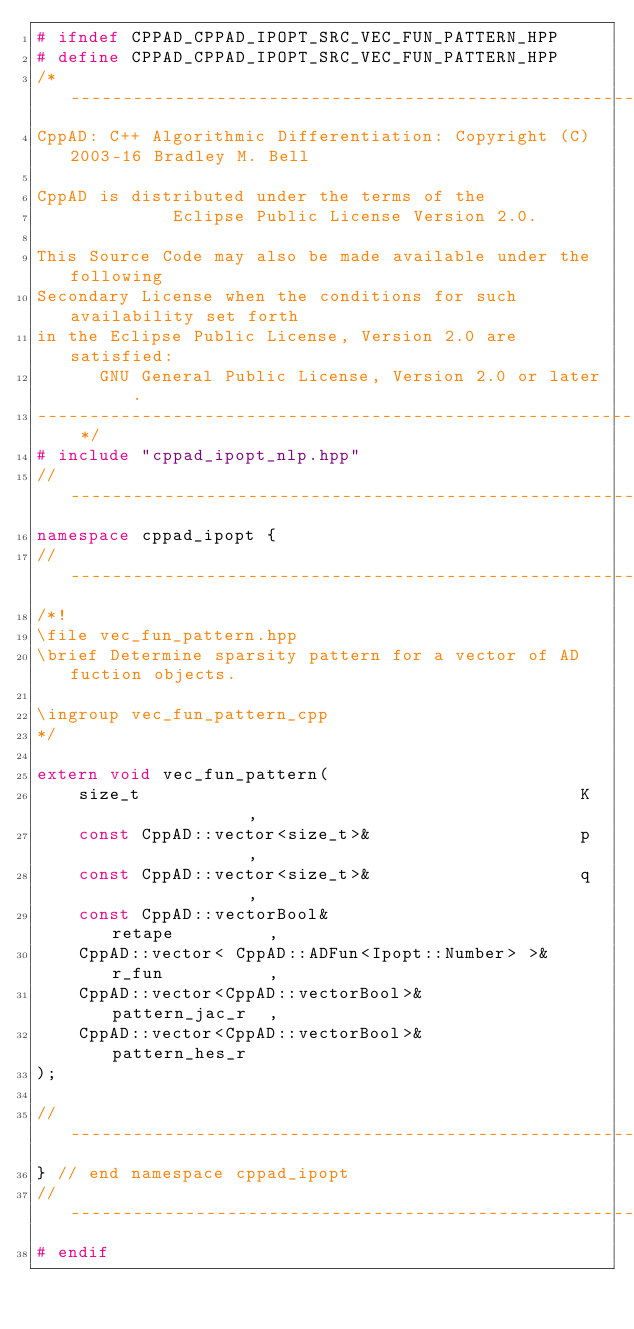Convert code to text. <code><loc_0><loc_0><loc_500><loc_500><_C++_># ifndef CPPAD_CPPAD_IPOPT_SRC_VEC_FUN_PATTERN_HPP
# define CPPAD_CPPAD_IPOPT_SRC_VEC_FUN_PATTERN_HPP
/* --------------------------------------------------------------------------
CppAD: C++ Algorithmic Differentiation: Copyright (C) 2003-16 Bradley M. Bell

CppAD is distributed under the terms of the
             Eclipse Public License Version 2.0.

This Source Code may also be made available under the following
Secondary License when the conditions for such availability set forth
in the Eclipse Public License, Version 2.0 are satisfied:
      GNU General Public License, Version 2.0 or later.
---------------------------------------------------------------------------- */
# include "cppad_ipopt_nlp.hpp"
// ---------------------------------------------------------------------------
namespace cppad_ipopt {
// ---------------------------------------------------------------------------
/*!
\file vec_fun_pattern.hpp
\brief Determine sparsity pattern for a vector of AD fuction objects.

\ingroup vec_fun_pattern_cpp
*/

extern void vec_fun_pattern(
    size_t                                          K              ,
    const CppAD::vector<size_t>&                    p              ,
    const CppAD::vector<size_t>&                    q              ,
    const CppAD::vectorBool&                        retape         ,
    CppAD::vector< CppAD::ADFun<Ipopt::Number> >&   r_fun          ,
    CppAD::vector<CppAD::vectorBool>&               pattern_jac_r  ,
    CppAD::vector<CppAD::vectorBool>&               pattern_hes_r
);

// ---------------------------------------------------------------------------
} // end namespace cppad_ipopt
// ---------------------------------------------------------------------------
# endif
</code> 